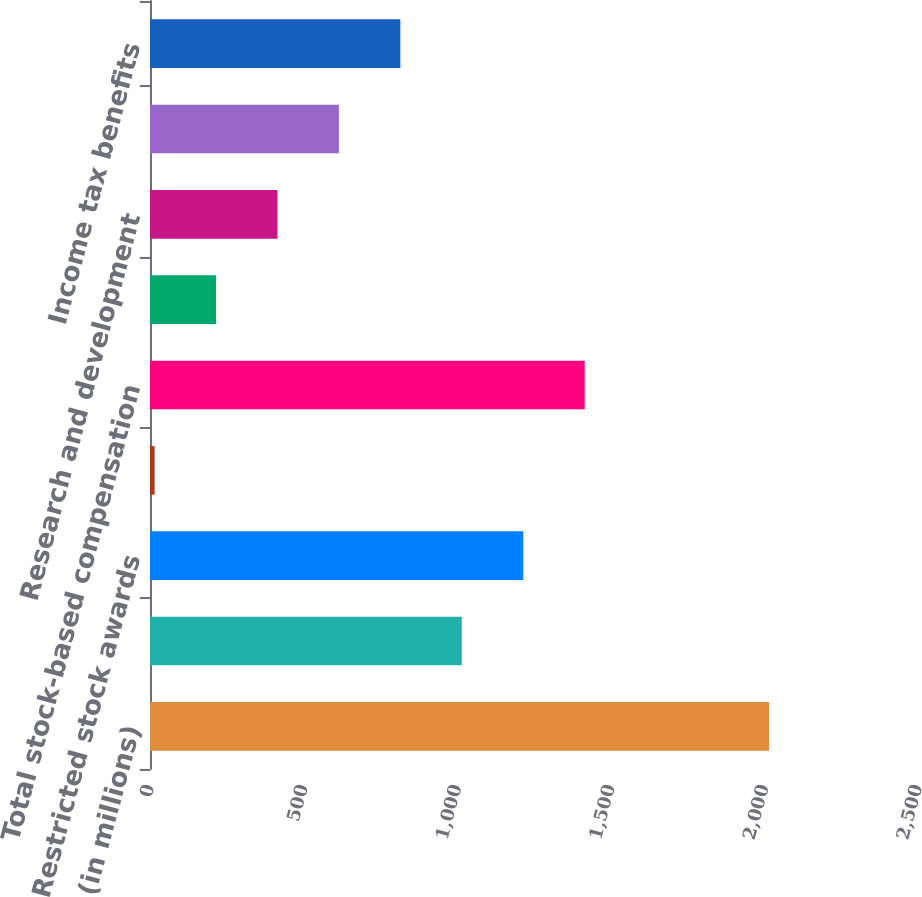<chart> <loc_0><loc_0><loc_500><loc_500><bar_chart><fcel>(in millions)<fcel>Stock options<fcel>Restricted stock awards<fcel>Employees stock purchase plan<fcel>Total stock-based compensation<fcel>Cost of products sold<fcel>Research and development<fcel>Selling general and<fcel>Income tax benefits<nl><fcel>2015<fcel>1015<fcel>1215<fcel>15<fcel>1415<fcel>215<fcel>415<fcel>615<fcel>815<nl></chart> 